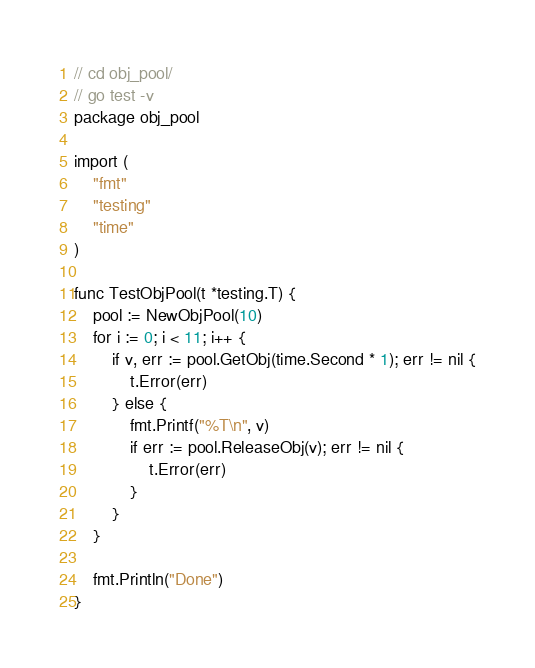Convert code to text. <code><loc_0><loc_0><loc_500><loc_500><_Go_>// cd obj_pool/
// go test -v
package obj_pool

import (
	"fmt"
	"testing"
	"time"
)

func TestObjPool(t *testing.T) {
	pool := NewObjPool(10)
	for i := 0; i < 11; i++ {
		if v, err := pool.GetObj(time.Second * 1); err != nil {
			t.Error(err)
		} else {
			fmt.Printf("%T\n", v)
			if err := pool.ReleaseObj(v); err != nil {
				t.Error(err)
			}
		}
	}

	fmt.Println("Done")
}
</code> 